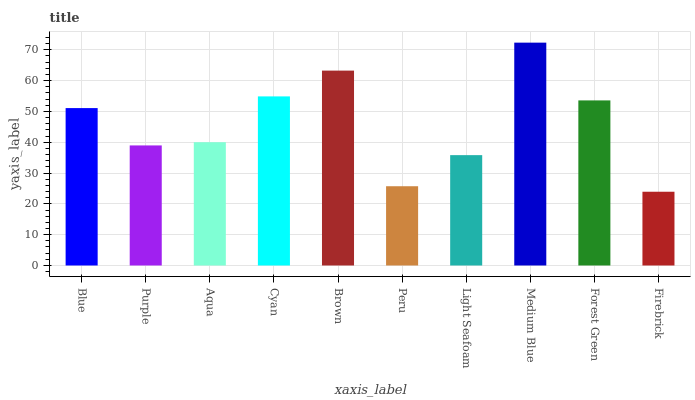Is Firebrick the minimum?
Answer yes or no. Yes. Is Medium Blue the maximum?
Answer yes or no. Yes. Is Purple the minimum?
Answer yes or no. No. Is Purple the maximum?
Answer yes or no. No. Is Blue greater than Purple?
Answer yes or no. Yes. Is Purple less than Blue?
Answer yes or no. Yes. Is Purple greater than Blue?
Answer yes or no. No. Is Blue less than Purple?
Answer yes or no. No. Is Blue the high median?
Answer yes or no. Yes. Is Aqua the low median?
Answer yes or no. Yes. Is Medium Blue the high median?
Answer yes or no. No. Is Light Seafoam the low median?
Answer yes or no. No. 